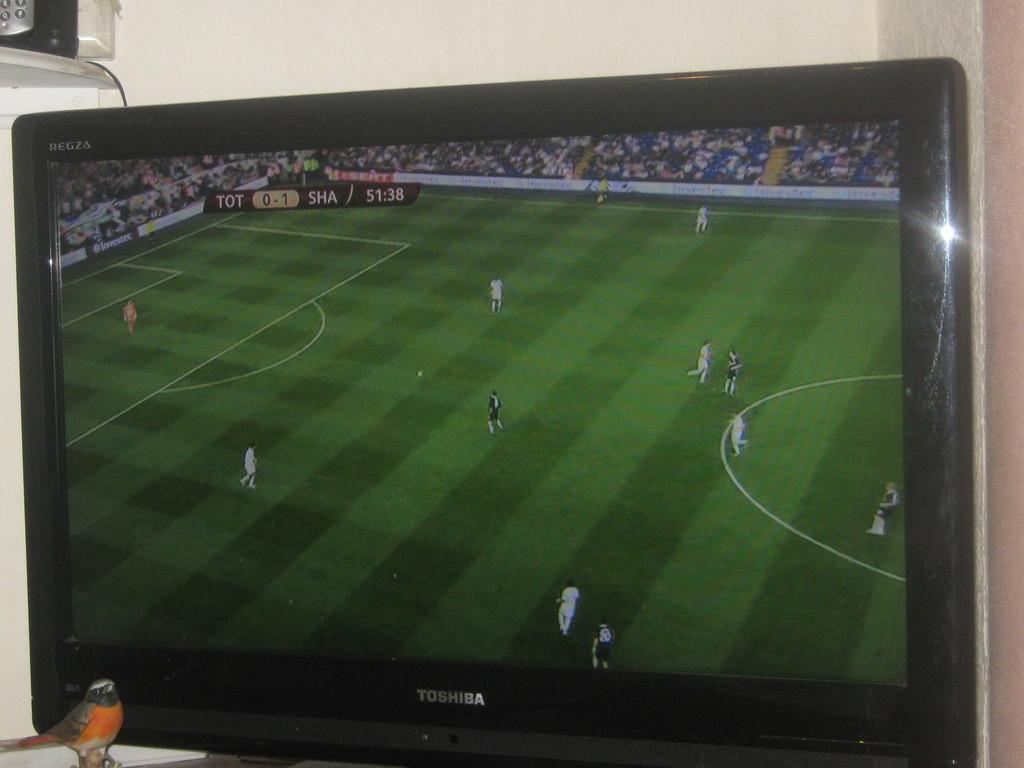Provide a one-sentence caption for the provided image. a television shows the image of soccer players on a Toshiba. 